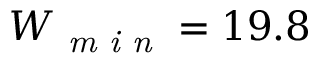<formula> <loc_0><loc_0><loc_500><loc_500>W _ { \min } = 1 9 . 8</formula> 